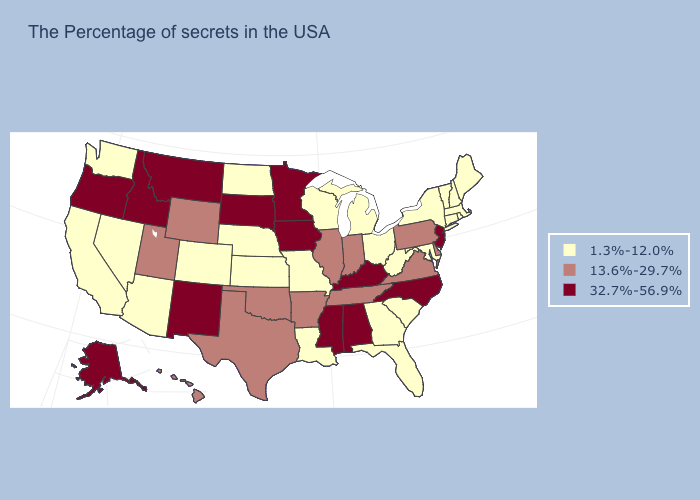Name the states that have a value in the range 1.3%-12.0%?
Short answer required. Maine, Massachusetts, Rhode Island, New Hampshire, Vermont, Connecticut, New York, Maryland, South Carolina, West Virginia, Ohio, Florida, Georgia, Michigan, Wisconsin, Louisiana, Missouri, Kansas, Nebraska, North Dakota, Colorado, Arizona, Nevada, California, Washington. Which states have the lowest value in the USA?
Concise answer only. Maine, Massachusetts, Rhode Island, New Hampshire, Vermont, Connecticut, New York, Maryland, South Carolina, West Virginia, Ohio, Florida, Georgia, Michigan, Wisconsin, Louisiana, Missouri, Kansas, Nebraska, North Dakota, Colorado, Arizona, Nevada, California, Washington. What is the value of Washington?
Be succinct. 1.3%-12.0%. Does Louisiana have the highest value in the USA?
Short answer required. No. What is the lowest value in the USA?
Answer briefly. 1.3%-12.0%. Among the states that border South Carolina , which have the highest value?
Short answer required. North Carolina. Name the states that have a value in the range 32.7%-56.9%?
Give a very brief answer. New Jersey, North Carolina, Kentucky, Alabama, Mississippi, Minnesota, Iowa, South Dakota, New Mexico, Montana, Idaho, Oregon, Alaska. Name the states that have a value in the range 13.6%-29.7%?
Keep it brief. Delaware, Pennsylvania, Virginia, Indiana, Tennessee, Illinois, Arkansas, Oklahoma, Texas, Wyoming, Utah, Hawaii. Name the states that have a value in the range 13.6%-29.7%?
Keep it brief. Delaware, Pennsylvania, Virginia, Indiana, Tennessee, Illinois, Arkansas, Oklahoma, Texas, Wyoming, Utah, Hawaii. What is the value of Pennsylvania?
Quick response, please. 13.6%-29.7%. What is the value of Virginia?
Quick response, please. 13.6%-29.7%. Among the states that border Indiana , does Michigan have the highest value?
Be succinct. No. Does Georgia have a lower value than Pennsylvania?
Give a very brief answer. Yes. Among the states that border Mississippi , which have the lowest value?
Be succinct. Louisiana. What is the value of Montana?
Concise answer only. 32.7%-56.9%. 